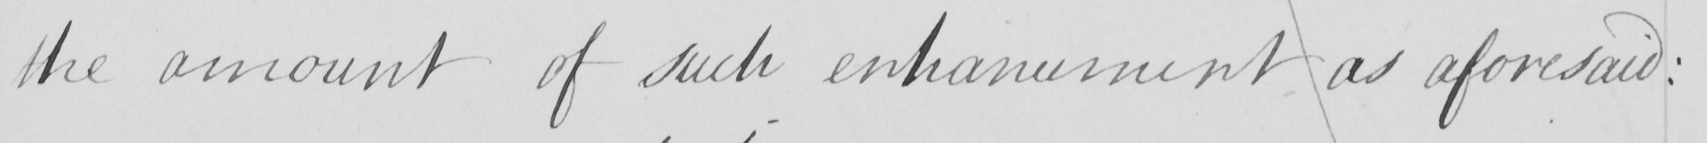Please transcribe the handwritten text in this image. the amount of such enhancement as aforesaid : 